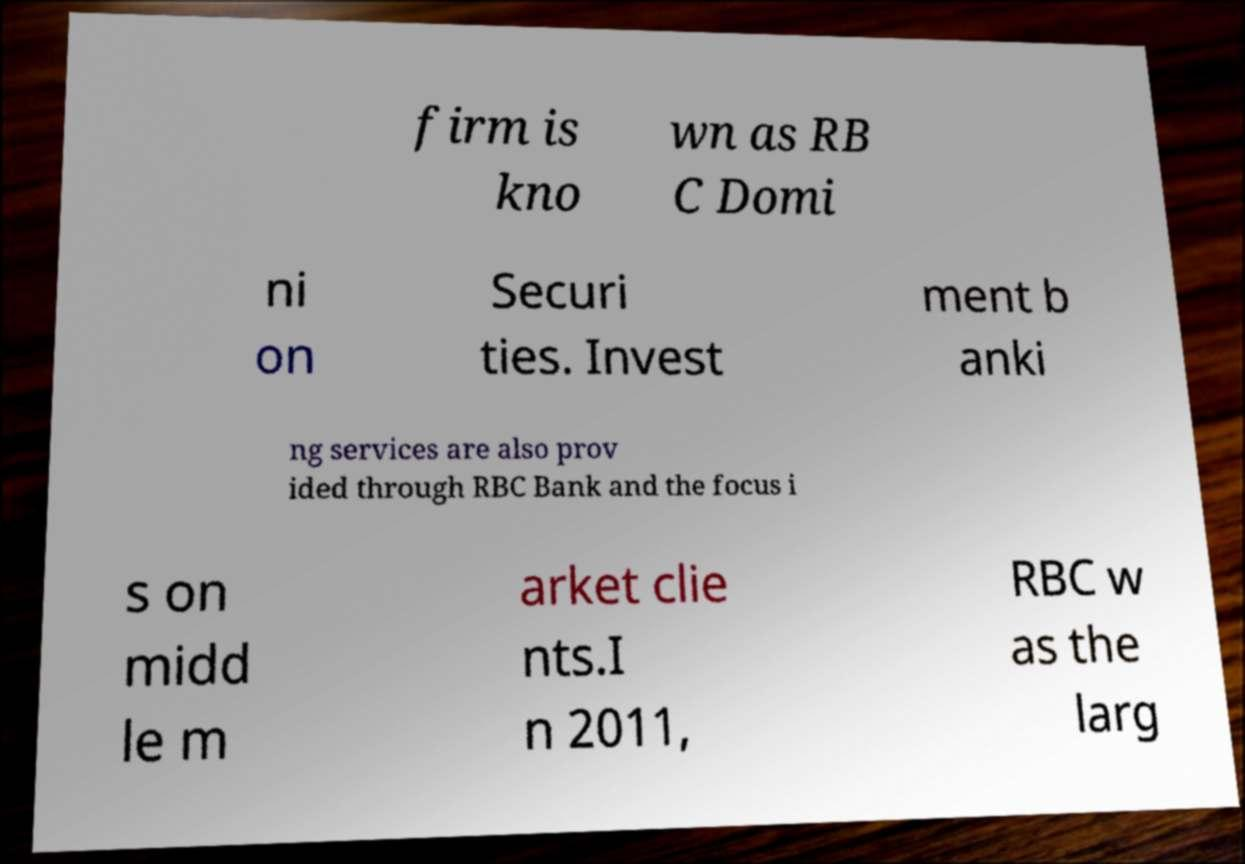I need the written content from this picture converted into text. Can you do that? firm is kno wn as RB C Domi ni on Securi ties. Invest ment b anki ng services are also prov ided through RBC Bank and the focus i s on midd le m arket clie nts.I n 2011, RBC w as the larg 